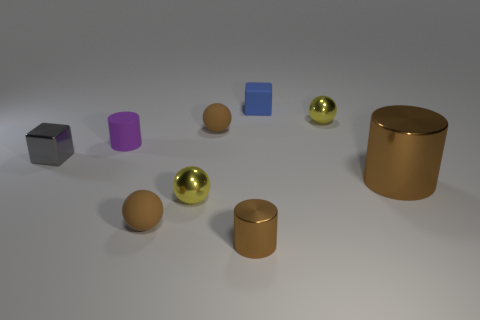There is a cylinder left of the brown ball behind the gray shiny cube; is there a small brown cylinder that is behind it?
Your answer should be very brief. No. What material is the purple cylinder?
Your answer should be very brief. Rubber. What number of other things are the same shape as the tiny blue rubber thing?
Your answer should be very brief. 1. Is the big brown object the same shape as the gray thing?
Your answer should be compact. No. What number of objects are small purple things behind the gray block or gray blocks to the left of the tiny purple cylinder?
Your response must be concise. 2. How many objects are big yellow shiny cubes or blue rubber objects?
Ensure brevity in your answer.  1. There is a brown shiny cylinder that is in front of the big brown cylinder; how many tiny balls are right of it?
Your answer should be very brief. 1. How many other objects are the same size as the gray shiny block?
Give a very brief answer. 7. There is another metal cylinder that is the same color as the tiny metallic cylinder; what size is it?
Your response must be concise. Large. Does the small brown matte thing that is in front of the purple rubber cylinder have the same shape as the tiny blue matte thing?
Make the answer very short. No. 